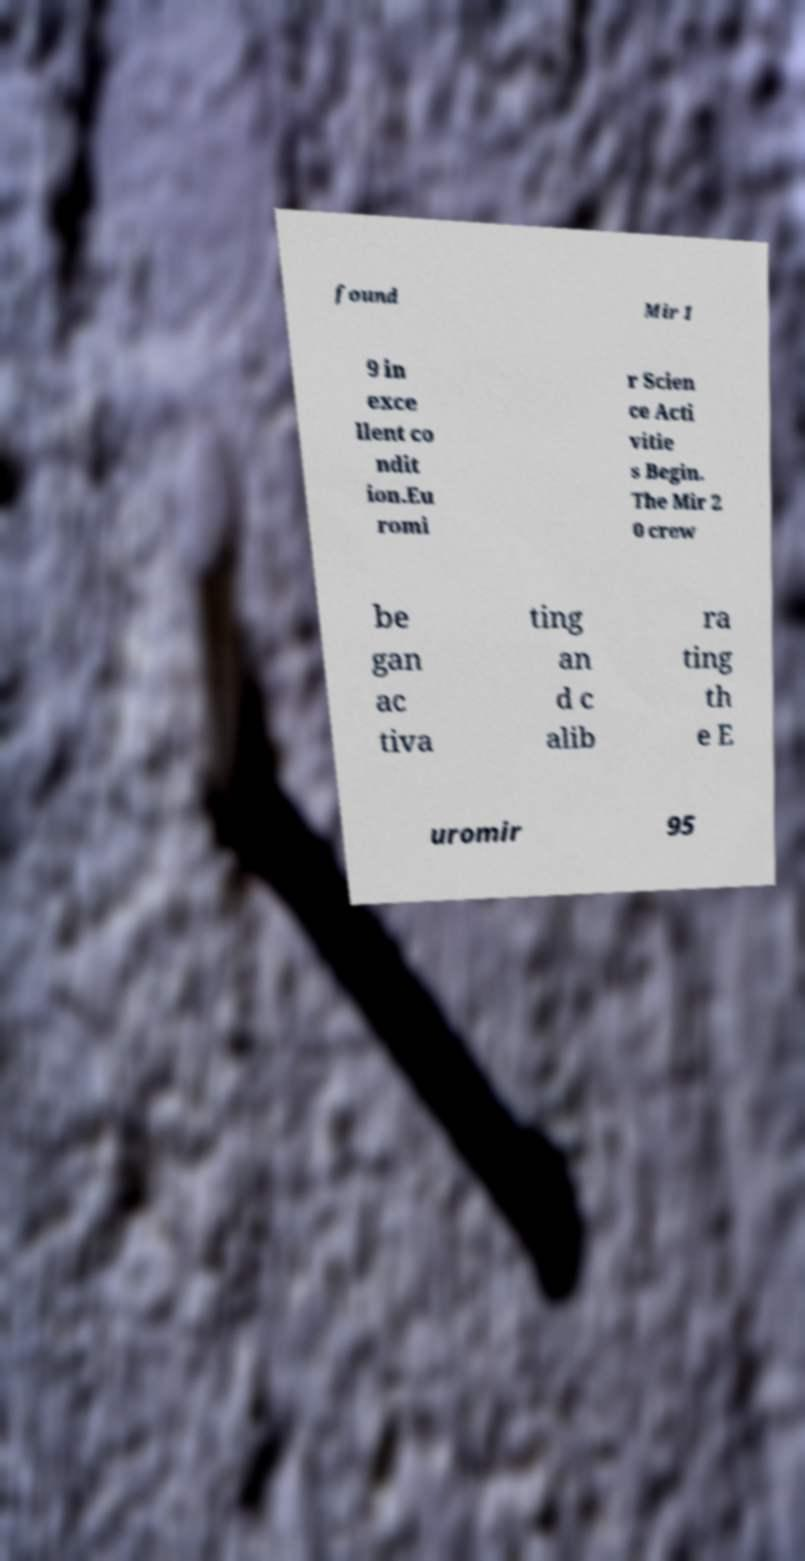Could you extract and type out the text from this image? found Mir 1 9 in exce llent co ndit ion.Eu romi r Scien ce Acti vitie s Begin. The Mir 2 0 crew be gan ac tiva ting an d c alib ra ting th e E uromir 95 